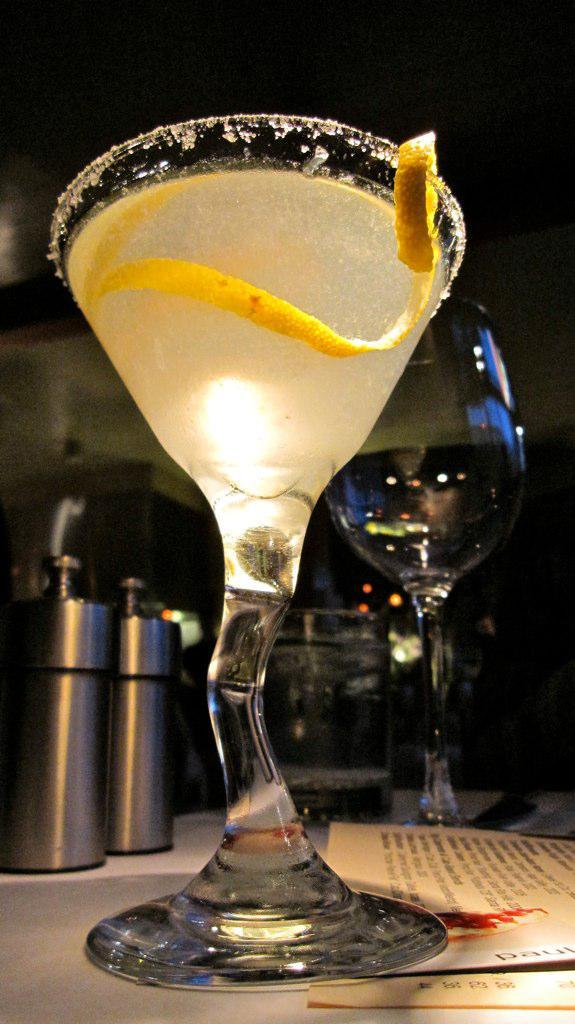What is in the glass that is visible in the image? There is a glass with a drink in the image. What other objects can be seen behind the glass? There are two objects behind the glass. Can you describe the second glass in the image? There is an empty glass in the image, and the background behind it is blurry. What type of wax is being used to create the afterthought in the image? There is no wax or afterthought present in the image. What achievements has the achiever in the image accomplished? There is no achiever or achievements mentioned in the image. 